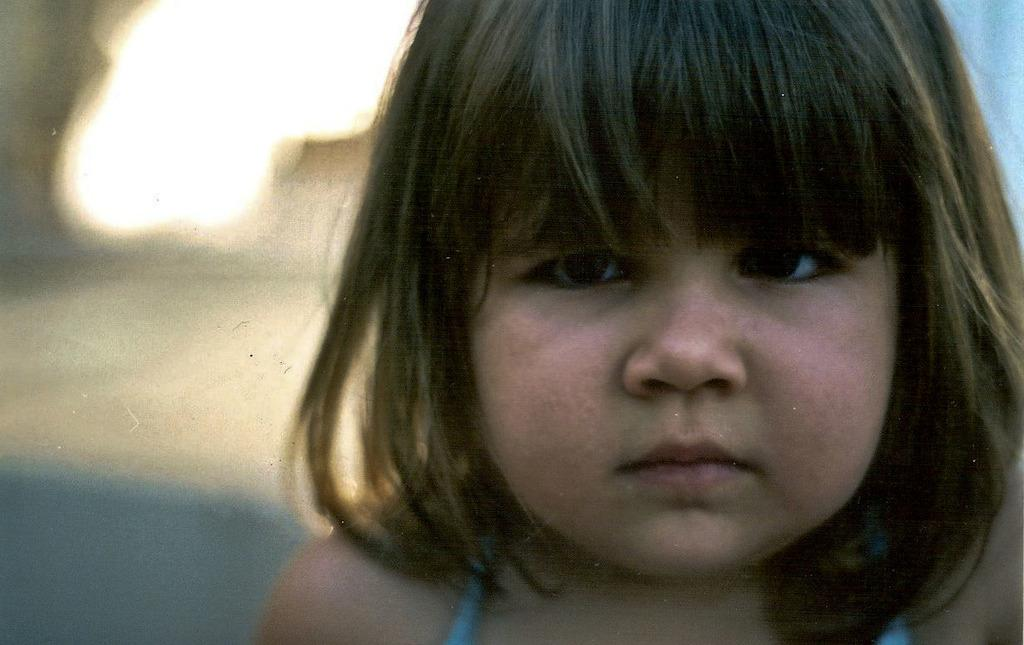Who is the main subject in the image? There is a girl in the image. What can be observed about the background of the image? The background of the image is blurred. What type of oatmeal is the girl eating in the image? There is no oatmeal present in the image. What is the girl's relationship to the queen in the image? There is no queen present in the image, so it is not possible to determine any relationship between the girl and a queen. 